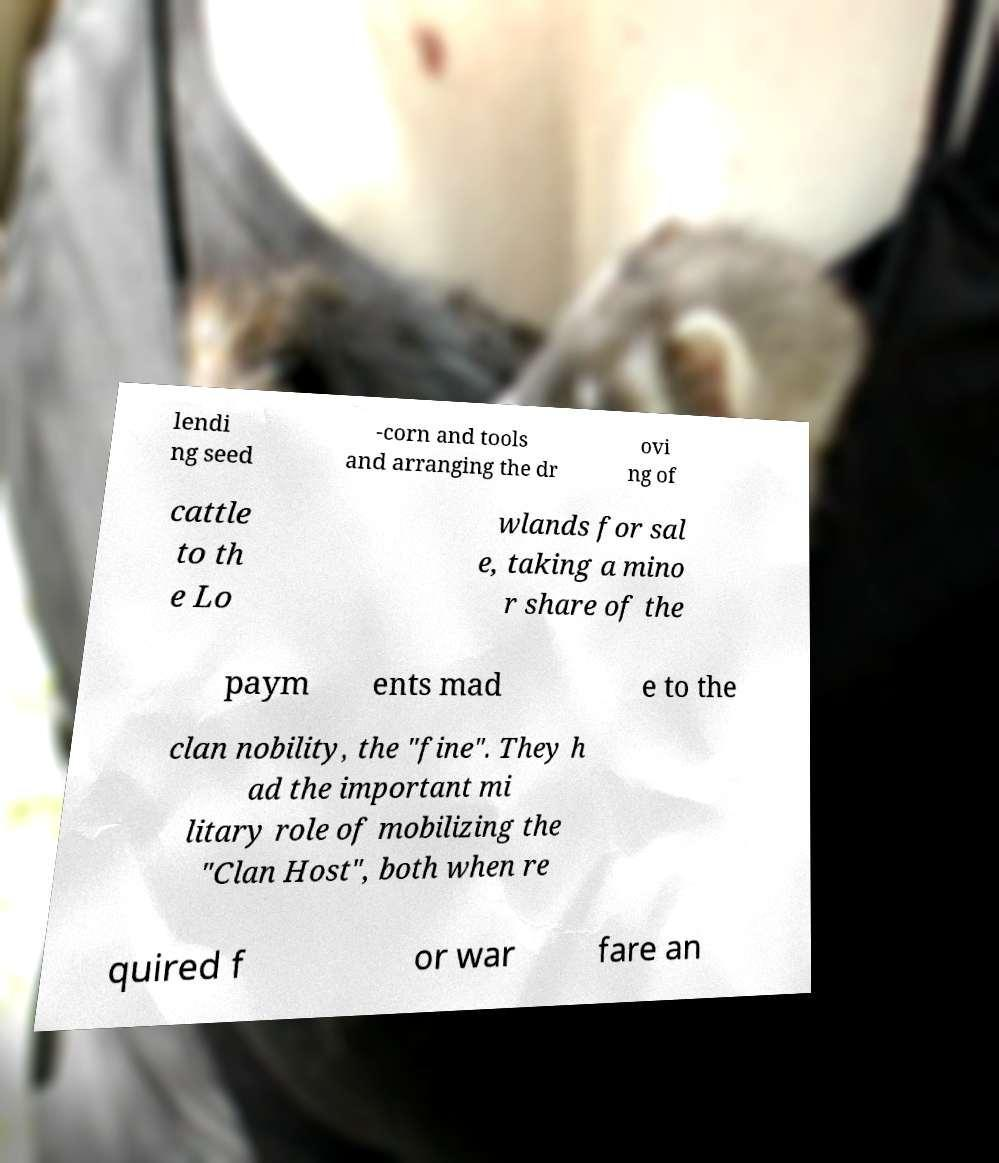For documentation purposes, I need the text within this image transcribed. Could you provide that? lendi ng seed -corn and tools and arranging the dr ovi ng of cattle to th e Lo wlands for sal e, taking a mino r share of the paym ents mad e to the clan nobility, the "fine". They h ad the important mi litary role of mobilizing the "Clan Host", both when re quired f or war fare an 